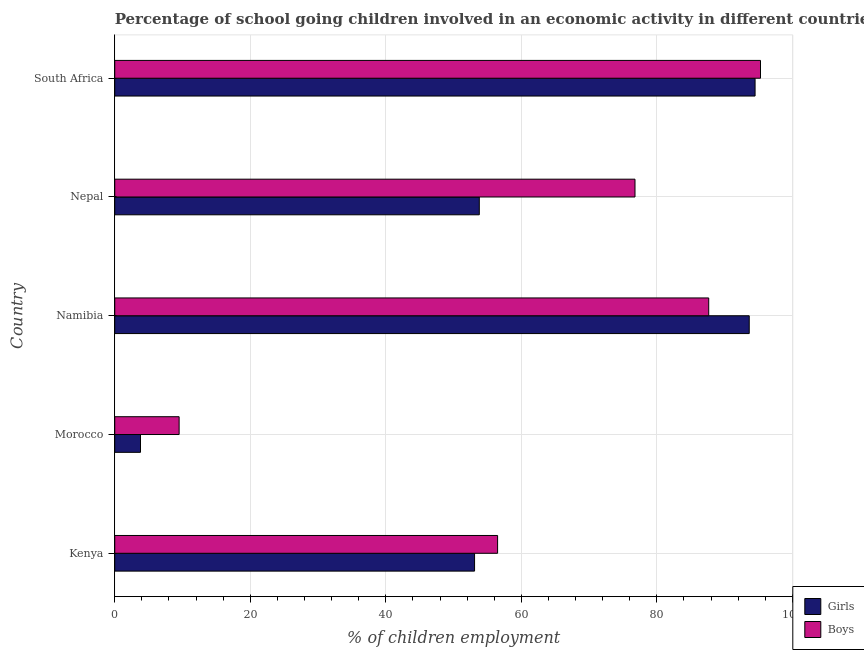How many different coloured bars are there?
Your response must be concise. 2. What is the label of the 2nd group of bars from the top?
Your response must be concise. Nepal. What is the percentage of school going girls in Nepal?
Offer a very short reply. 53.8. Across all countries, what is the maximum percentage of school going boys?
Your response must be concise. 95.3. Across all countries, what is the minimum percentage of school going girls?
Ensure brevity in your answer.  3.8. In which country was the percentage of school going girls maximum?
Your response must be concise. South Africa. In which country was the percentage of school going girls minimum?
Give a very brief answer. Morocco. What is the total percentage of school going boys in the graph?
Provide a short and direct response. 325.73. What is the difference between the percentage of school going girls in Morocco and that in South Africa?
Your answer should be compact. -90.7. What is the difference between the percentage of school going boys in Kenya and the percentage of school going girls in South Africa?
Ensure brevity in your answer.  -38. What is the average percentage of school going girls per country?
Ensure brevity in your answer.  59.77. What is the difference between the percentage of school going girls and percentage of school going boys in Nepal?
Provide a succinct answer. -22.98. In how many countries, is the percentage of school going boys greater than 56 %?
Offer a very short reply. 4. What is the ratio of the percentage of school going girls in Kenya to that in South Africa?
Provide a short and direct response. 0.56. Is the difference between the percentage of school going girls in Kenya and South Africa greater than the difference between the percentage of school going boys in Kenya and South Africa?
Provide a short and direct response. No. What is the difference between the highest and the second highest percentage of school going girls?
Keep it short and to the point. 0.86. What is the difference between the highest and the lowest percentage of school going boys?
Your answer should be very brief. 85.8. What does the 2nd bar from the top in Morocco represents?
Provide a short and direct response. Girls. What does the 1st bar from the bottom in Nepal represents?
Provide a succinct answer. Girls. How many bars are there?
Keep it short and to the point. 10. Are the values on the major ticks of X-axis written in scientific E-notation?
Your answer should be very brief. No. Does the graph contain grids?
Give a very brief answer. Yes. Where does the legend appear in the graph?
Your answer should be compact. Bottom right. How many legend labels are there?
Your response must be concise. 2. How are the legend labels stacked?
Make the answer very short. Vertical. What is the title of the graph?
Provide a short and direct response. Percentage of school going children involved in an economic activity in different countries. Does "Death rate" appear as one of the legend labels in the graph?
Your answer should be compact. No. What is the label or title of the X-axis?
Provide a short and direct response. % of children employment. What is the % of children employment of Girls in Kenya?
Offer a very short reply. 53.1. What is the % of children employment in Boys in Kenya?
Provide a short and direct response. 56.5. What is the % of children employment of Girls in Morocco?
Make the answer very short. 3.8. What is the % of children employment in Girls in Namibia?
Make the answer very short. 93.64. What is the % of children employment in Boys in Namibia?
Offer a terse response. 87.66. What is the % of children employment in Girls in Nepal?
Provide a succinct answer. 53.8. What is the % of children employment of Boys in Nepal?
Offer a very short reply. 76.78. What is the % of children employment of Girls in South Africa?
Offer a terse response. 94.5. What is the % of children employment in Boys in South Africa?
Make the answer very short. 95.3. Across all countries, what is the maximum % of children employment of Girls?
Provide a short and direct response. 94.5. Across all countries, what is the maximum % of children employment of Boys?
Your answer should be very brief. 95.3. Across all countries, what is the minimum % of children employment in Girls?
Give a very brief answer. 3.8. What is the total % of children employment in Girls in the graph?
Your answer should be compact. 298.84. What is the total % of children employment in Boys in the graph?
Keep it short and to the point. 325.73. What is the difference between the % of children employment in Girls in Kenya and that in Morocco?
Ensure brevity in your answer.  49.3. What is the difference between the % of children employment of Boys in Kenya and that in Morocco?
Offer a very short reply. 47. What is the difference between the % of children employment in Girls in Kenya and that in Namibia?
Offer a very short reply. -40.54. What is the difference between the % of children employment of Boys in Kenya and that in Namibia?
Your response must be concise. -31.16. What is the difference between the % of children employment in Girls in Kenya and that in Nepal?
Offer a terse response. -0.7. What is the difference between the % of children employment in Boys in Kenya and that in Nepal?
Make the answer very short. -20.28. What is the difference between the % of children employment in Girls in Kenya and that in South Africa?
Offer a terse response. -41.4. What is the difference between the % of children employment of Boys in Kenya and that in South Africa?
Make the answer very short. -38.8. What is the difference between the % of children employment in Girls in Morocco and that in Namibia?
Your answer should be compact. -89.84. What is the difference between the % of children employment in Boys in Morocco and that in Namibia?
Give a very brief answer. -78.16. What is the difference between the % of children employment of Boys in Morocco and that in Nepal?
Ensure brevity in your answer.  -67.28. What is the difference between the % of children employment of Girls in Morocco and that in South Africa?
Your answer should be compact. -90.7. What is the difference between the % of children employment in Boys in Morocco and that in South Africa?
Your answer should be compact. -85.8. What is the difference between the % of children employment of Girls in Namibia and that in Nepal?
Make the answer very short. 39.84. What is the difference between the % of children employment of Boys in Namibia and that in Nepal?
Make the answer very short. 10.88. What is the difference between the % of children employment of Girls in Namibia and that in South Africa?
Offer a terse response. -0.86. What is the difference between the % of children employment of Boys in Namibia and that in South Africa?
Offer a terse response. -7.64. What is the difference between the % of children employment of Girls in Nepal and that in South Africa?
Offer a very short reply. -40.7. What is the difference between the % of children employment of Boys in Nepal and that in South Africa?
Provide a short and direct response. -18.52. What is the difference between the % of children employment of Girls in Kenya and the % of children employment of Boys in Morocco?
Keep it short and to the point. 43.6. What is the difference between the % of children employment in Girls in Kenya and the % of children employment in Boys in Namibia?
Provide a short and direct response. -34.56. What is the difference between the % of children employment of Girls in Kenya and the % of children employment of Boys in Nepal?
Offer a terse response. -23.68. What is the difference between the % of children employment in Girls in Kenya and the % of children employment in Boys in South Africa?
Your answer should be compact. -42.2. What is the difference between the % of children employment in Girls in Morocco and the % of children employment in Boys in Namibia?
Offer a terse response. -83.86. What is the difference between the % of children employment of Girls in Morocco and the % of children employment of Boys in Nepal?
Offer a very short reply. -72.98. What is the difference between the % of children employment in Girls in Morocco and the % of children employment in Boys in South Africa?
Keep it short and to the point. -91.5. What is the difference between the % of children employment in Girls in Namibia and the % of children employment in Boys in Nepal?
Provide a succinct answer. 16.86. What is the difference between the % of children employment in Girls in Namibia and the % of children employment in Boys in South Africa?
Offer a very short reply. -1.66. What is the difference between the % of children employment in Girls in Nepal and the % of children employment in Boys in South Africa?
Make the answer very short. -41.5. What is the average % of children employment in Girls per country?
Provide a short and direct response. 59.77. What is the average % of children employment of Boys per country?
Your answer should be very brief. 65.15. What is the difference between the % of children employment in Girls and % of children employment in Boys in Morocco?
Your answer should be compact. -5.7. What is the difference between the % of children employment in Girls and % of children employment in Boys in Namibia?
Your answer should be compact. 5.98. What is the difference between the % of children employment of Girls and % of children employment of Boys in Nepal?
Offer a very short reply. -22.98. What is the ratio of the % of children employment of Girls in Kenya to that in Morocco?
Give a very brief answer. 13.97. What is the ratio of the % of children employment of Boys in Kenya to that in Morocco?
Your response must be concise. 5.95. What is the ratio of the % of children employment of Girls in Kenya to that in Namibia?
Keep it short and to the point. 0.57. What is the ratio of the % of children employment of Boys in Kenya to that in Namibia?
Give a very brief answer. 0.64. What is the ratio of the % of children employment in Girls in Kenya to that in Nepal?
Offer a terse response. 0.99. What is the ratio of the % of children employment of Boys in Kenya to that in Nepal?
Provide a short and direct response. 0.74. What is the ratio of the % of children employment in Girls in Kenya to that in South Africa?
Your response must be concise. 0.56. What is the ratio of the % of children employment in Boys in Kenya to that in South Africa?
Your answer should be compact. 0.59. What is the ratio of the % of children employment of Girls in Morocco to that in Namibia?
Your answer should be compact. 0.04. What is the ratio of the % of children employment in Boys in Morocco to that in Namibia?
Offer a very short reply. 0.11. What is the ratio of the % of children employment in Girls in Morocco to that in Nepal?
Provide a succinct answer. 0.07. What is the ratio of the % of children employment in Boys in Morocco to that in Nepal?
Your answer should be compact. 0.12. What is the ratio of the % of children employment of Girls in Morocco to that in South Africa?
Your answer should be compact. 0.04. What is the ratio of the % of children employment of Boys in Morocco to that in South Africa?
Offer a very short reply. 0.1. What is the ratio of the % of children employment in Girls in Namibia to that in Nepal?
Provide a succinct answer. 1.74. What is the ratio of the % of children employment in Boys in Namibia to that in Nepal?
Offer a very short reply. 1.14. What is the ratio of the % of children employment in Girls in Namibia to that in South Africa?
Provide a succinct answer. 0.99. What is the ratio of the % of children employment of Boys in Namibia to that in South Africa?
Offer a terse response. 0.92. What is the ratio of the % of children employment of Girls in Nepal to that in South Africa?
Provide a succinct answer. 0.57. What is the ratio of the % of children employment of Boys in Nepal to that in South Africa?
Offer a terse response. 0.81. What is the difference between the highest and the second highest % of children employment in Girls?
Offer a terse response. 0.86. What is the difference between the highest and the second highest % of children employment in Boys?
Your response must be concise. 7.64. What is the difference between the highest and the lowest % of children employment in Girls?
Provide a succinct answer. 90.7. What is the difference between the highest and the lowest % of children employment in Boys?
Make the answer very short. 85.8. 